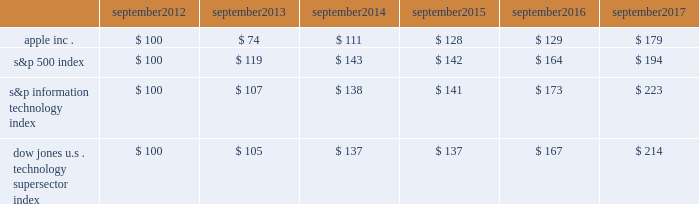Apple inc .
| 2017 form 10-k | 20 company stock performance the following graph shows a comparison of cumulative total shareholder return , calculated on a dividend reinvested basis , for the company , the s&p 500 index , the s&p information technology index and the dow jones u.s .
Technology supersector index for the five years ended september 30 , 2017 .
The graph assumes $ 100 was invested in each of the company 2019s common stock , the s&p 500 index , the s&p information technology index and the dow jones u.s .
Technology supersector index as of the market close on september 28 , 2012 .
Note that historic stock price performance is not necessarily indicative of future stock price performance .
* $ 100 invested on 9/28/12 in stock or index , including reinvestment of dividends .
Data points are the last day of each fiscal year for the company 2019s common stock and september 30th for indexes .
Copyright a9 2017 s&p , a division of mcgraw hill financial .
All rights reserved .
Copyright a9 2017 dow jones & co .
All rights reserved .
September september september september september september .

What was the change in the dow jones technology index between 2016 and 2017? 
Computations: (214 - 167)
Answer: 47.0. 